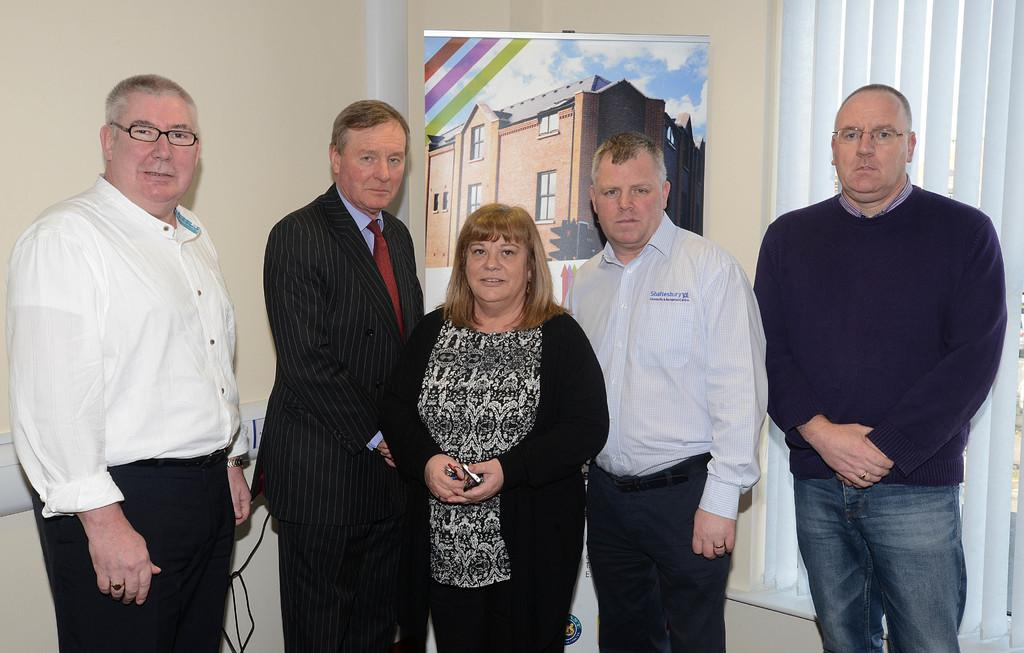What is happening in the image? There are people standing in the image. What can be seen in the background of the image? There is a board and a wall in the background of the image. What type of window treatment is present in the image? Blinds are present in the image. What type of stew is being served at the event in the image? There is no event or stew present in the image; it only shows people standing with a board and a wall in the background. 